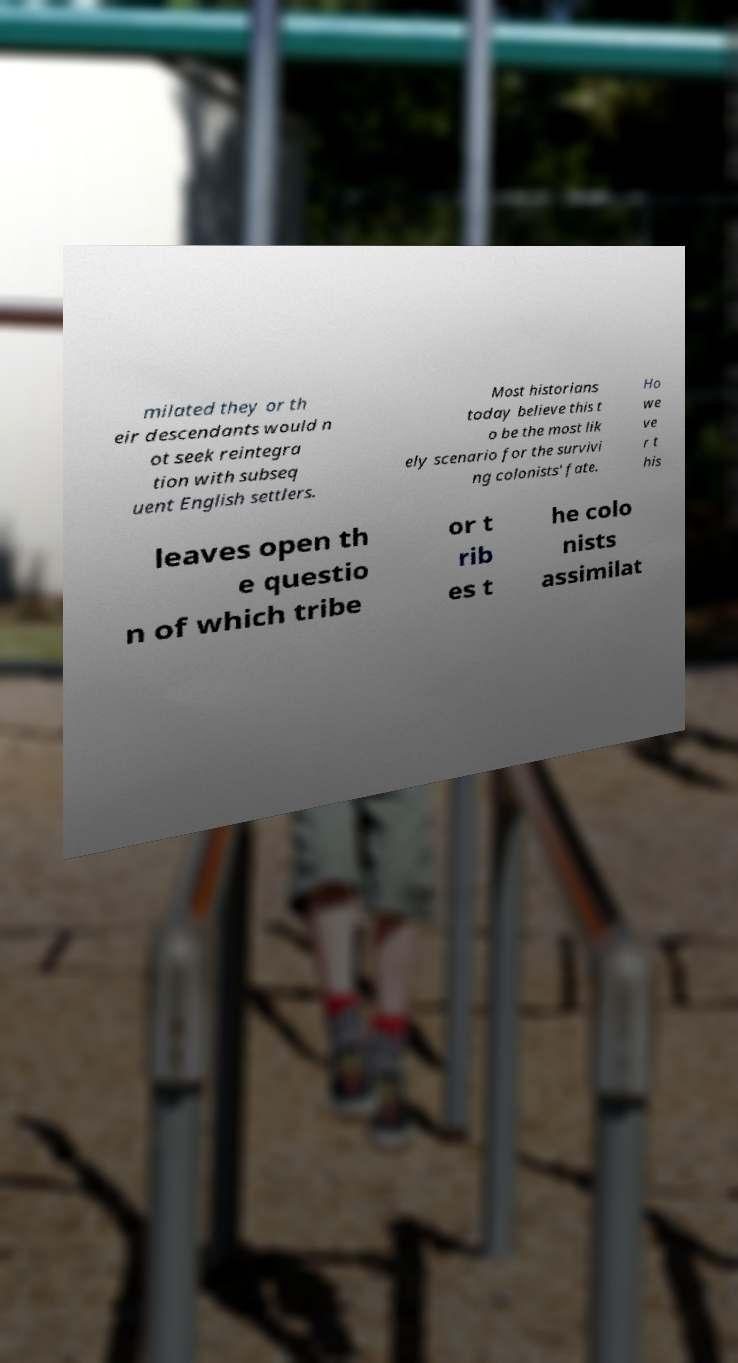Please read and relay the text visible in this image. What does it say? milated they or th eir descendants would n ot seek reintegra tion with subseq uent English settlers. Most historians today believe this t o be the most lik ely scenario for the survivi ng colonists' fate. Ho we ve r t his leaves open th e questio n of which tribe or t rib es t he colo nists assimilat 